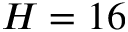<formula> <loc_0><loc_0><loc_500><loc_500>H = 1 6</formula> 